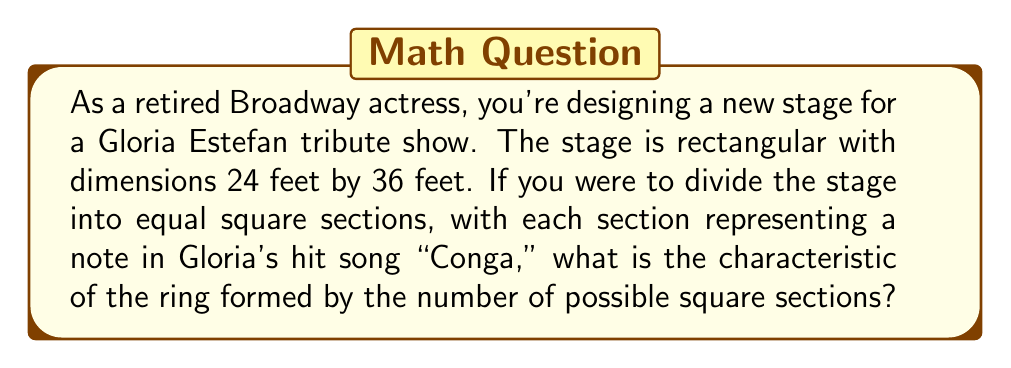Teach me how to tackle this problem. Let's approach this step-by-step:

1) First, we need to find the largest possible square sections that can evenly divide both dimensions of the stage. This is equivalent to finding the greatest common divisor (GCD) of 24 and 36.

2) To find the GCD, we can use the Euclidean algorithm:
   $36 = 1 \times 24 + 12$
   $24 = 2 \times 12 + 0$

   Therefore, the GCD of 24 and 36 is 12.

3) This means the largest square sections we can create are 12 feet by 12 feet.

4) Now, let's calculate how many such sections we can fit on the stage:
   $\text{Number of sections} = \frac{24 \times 36}{12 \times 12} = \frac{864}{144} = 6$

5) In ring theory, the characteristic of a ring is the smallest positive integer $n$ such that:

   $\underbrace{1 + 1 + ... + 1}_{n \text{ times}} = 0$

   If no such integer exists, the ring has characteristic 0.

6) In this case, we have 6 sections. We need to determine if there's any positive integer $n$ less than or equal to 6 that satisfies the above condition.

7) Let's check:
   For $n = 1$: $1 \neq 0$
   For $n = 2$: $1 + 1 = 2 \neq 0$
   For $n = 3$: $1 + 1 + 1 = 3 \neq 0$
   For $n = 4$: $1 + 1 + 1 + 1 = 4 \neq 0$
   For $n = 5$: $1 + 1 + 1 + 1 + 1 = 5 \neq 0$
   For $n = 6$: $1 + 1 + 1 + 1 + 1 + 1 = 6 \neq 0$

8) Since no value of $n$ up to and including 6 satisfies the condition, the characteristic of this ring is 0.
Answer: The characteristic of the ring is 0. 